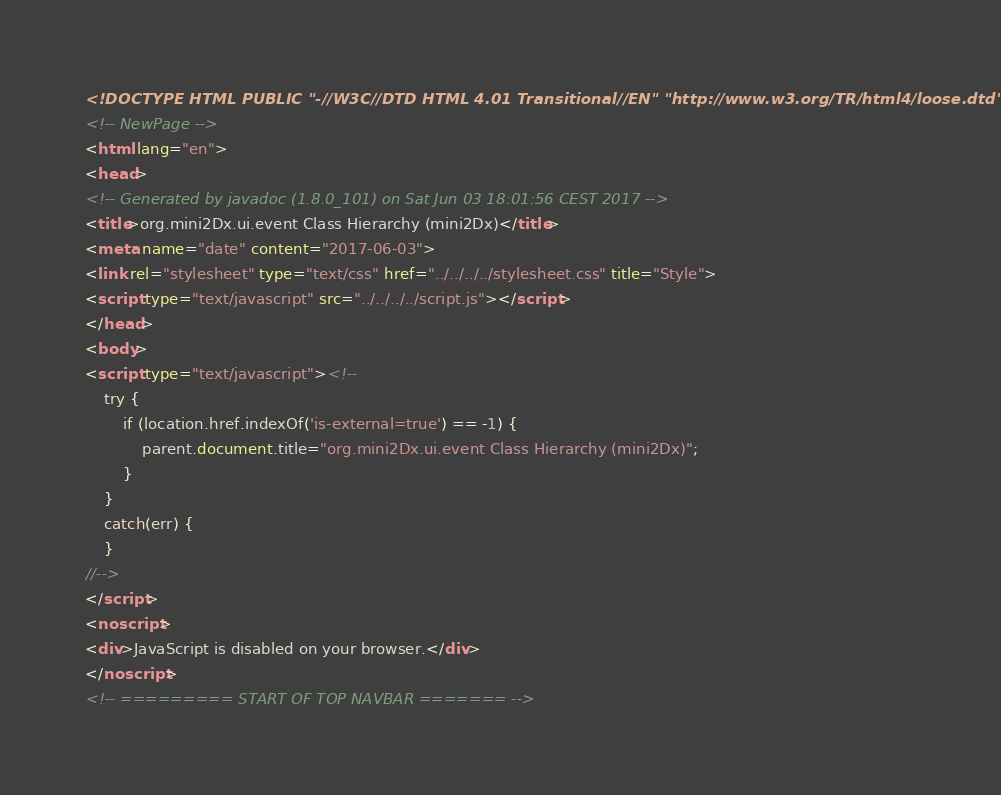Convert code to text. <code><loc_0><loc_0><loc_500><loc_500><_HTML_><!DOCTYPE HTML PUBLIC "-//W3C//DTD HTML 4.01 Transitional//EN" "http://www.w3.org/TR/html4/loose.dtd">
<!-- NewPage -->
<html lang="en">
<head>
<!-- Generated by javadoc (1.8.0_101) on Sat Jun 03 18:01:56 CEST 2017 -->
<title>org.mini2Dx.ui.event Class Hierarchy (mini2Dx)</title>
<meta name="date" content="2017-06-03">
<link rel="stylesheet" type="text/css" href="../../../../stylesheet.css" title="Style">
<script type="text/javascript" src="../../../../script.js"></script>
</head>
<body>
<script type="text/javascript"><!--
    try {
        if (location.href.indexOf('is-external=true') == -1) {
            parent.document.title="org.mini2Dx.ui.event Class Hierarchy (mini2Dx)";
        }
    }
    catch(err) {
    }
//-->
</script>
<noscript>
<div>JavaScript is disabled on your browser.</div>
</noscript>
<!-- ========= START OF TOP NAVBAR ======= --></code> 